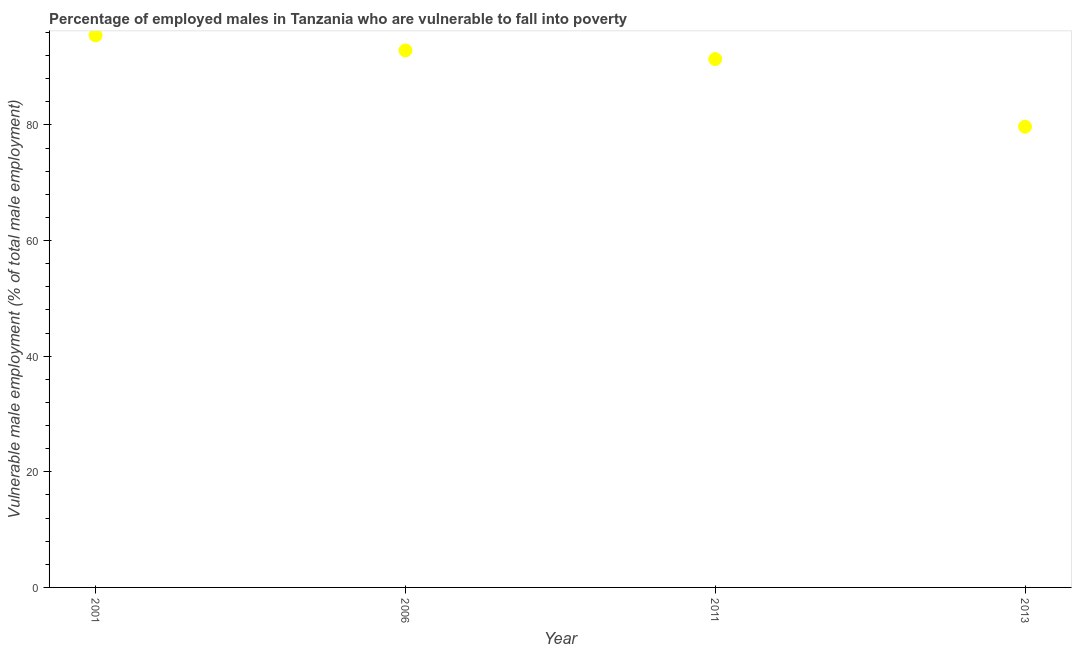What is the percentage of employed males who are vulnerable to fall into poverty in 2011?
Keep it short and to the point. 91.4. Across all years, what is the maximum percentage of employed males who are vulnerable to fall into poverty?
Ensure brevity in your answer.  95.5. Across all years, what is the minimum percentage of employed males who are vulnerable to fall into poverty?
Keep it short and to the point. 79.7. What is the sum of the percentage of employed males who are vulnerable to fall into poverty?
Give a very brief answer. 359.5. What is the difference between the percentage of employed males who are vulnerable to fall into poverty in 2011 and 2013?
Offer a very short reply. 11.7. What is the average percentage of employed males who are vulnerable to fall into poverty per year?
Your response must be concise. 89.88. What is the median percentage of employed males who are vulnerable to fall into poverty?
Provide a short and direct response. 92.15. In how many years, is the percentage of employed males who are vulnerable to fall into poverty greater than 12 %?
Give a very brief answer. 4. Do a majority of the years between 2013 and 2006 (inclusive) have percentage of employed males who are vulnerable to fall into poverty greater than 80 %?
Provide a succinct answer. No. What is the ratio of the percentage of employed males who are vulnerable to fall into poverty in 2001 to that in 2013?
Your answer should be very brief. 1.2. Is the percentage of employed males who are vulnerable to fall into poverty in 2001 less than that in 2011?
Keep it short and to the point. No. What is the difference between the highest and the second highest percentage of employed males who are vulnerable to fall into poverty?
Your answer should be very brief. 2.6. Is the sum of the percentage of employed males who are vulnerable to fall into poverty in 2011 and 2013 greater than the maximum percentage of employed males who are vulnerable to fall into poverty across all years?
Your answer should be compact. Yes. What is the difference between the highest and the lowest percentage of employed males who are vulnerable to fall into poverty?
Your answer should be very brief. 15.8. In how many years, is the percentage of employed males who are vulnerable to fall into poverty greater than the average percentage of employed males who are vulnerable to fall into poverty taken over all years?
Your answer should be very brief. 3. Does the percentage of employed males who are vulnerable to fall into poverty monotonically increase over the years?
Keep it short and to the point. No. How many dotlines are there?
Give a very brief answer. 1. How many years are there in the graph?
Provide a succinct answer. 4. What is the difference between two consecutive major ticks on the Y-axis?
Your answer should be compact. 20. Are the values on the major ticks of Y-axis written in scientific E-notation?
Provide a succinct answer. No. Does the graph contain grids?
Ensure brevity in your answer.  No. What is the title of the graph?
Provide a succinct answer. Percentage of employed males in Tanzania who are vulnerable to fall into poverty. What is the label or title of the X-axis?
Offer a very short reply. Year. What is the label or title of the Y-axis?
Provide a succinct answer. Vulnerable male employment (% of total male employment). What is the Vulnerable male employment (% of total male employment) in 2001?
Keep it short and to the point. 95.5. What is the Vulnerable male employment (% of total male employment) in 2006?
Keep it short and to the point. 92.9. What is the Vulnerable male employment (% of total male employment) in 2011?
Offer a very short reply. 91.4. What is the Vulnerable male employment (% of total male employment) in 2013?
Provide a short and direct response. 79.7. What is the difference between the Vulnerable male employment (% of total male employment) in 2001 and 2011?
Ensure brevity in your answer.  4.1. What is the difference between the Vulnerable male employment (% of total male employment) in 2001 and 2013?
Provide a succinct answer. 15.8. What is the difference between the Vulnerable male employment (% of total male employment) in 2011 and 2013?
Provide a short and direct response. 11.7. What is the ratio of the Vulnerable male employment (% of total male employment) in 2001 to that in 2006?
Give a very brief answer. 1.03. What is the ratio of the Vulnerable male employment (% of total male employment) in 2001 to that in 2011?
Offer a terse response. 1.04. What is the ratio of the Vulnerable male employment (% of total male employment) in 2001 to that in 2013?
Give a very brief answer. 1.2. What is the ratio of the Vulnerable male employment (% of total male employment) in 2006 to that in 2011?
Make the answer very short. 1.02. What is the ratio of the Vulnerable male employment (% of total male employment) in 2006 to that in 2013?
Provide a short and direct response. 1.17. What is the ratio of the Vulnerable male employment (% of total male employment) in 2011 to that in 2013?
Your answer should be very brief. 1.15. 